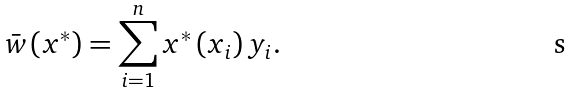Convert formula to latex. <formula><loc_0><loc_0><loc_500><loc_500>\text {\ } \bar { w } \left ( x ^ { \ast } \right ) = \sum _ { i = 1 } ^ { n } x ^ { \ast } \left ( x _ { i } \right ) y _ { i } .</formula> 